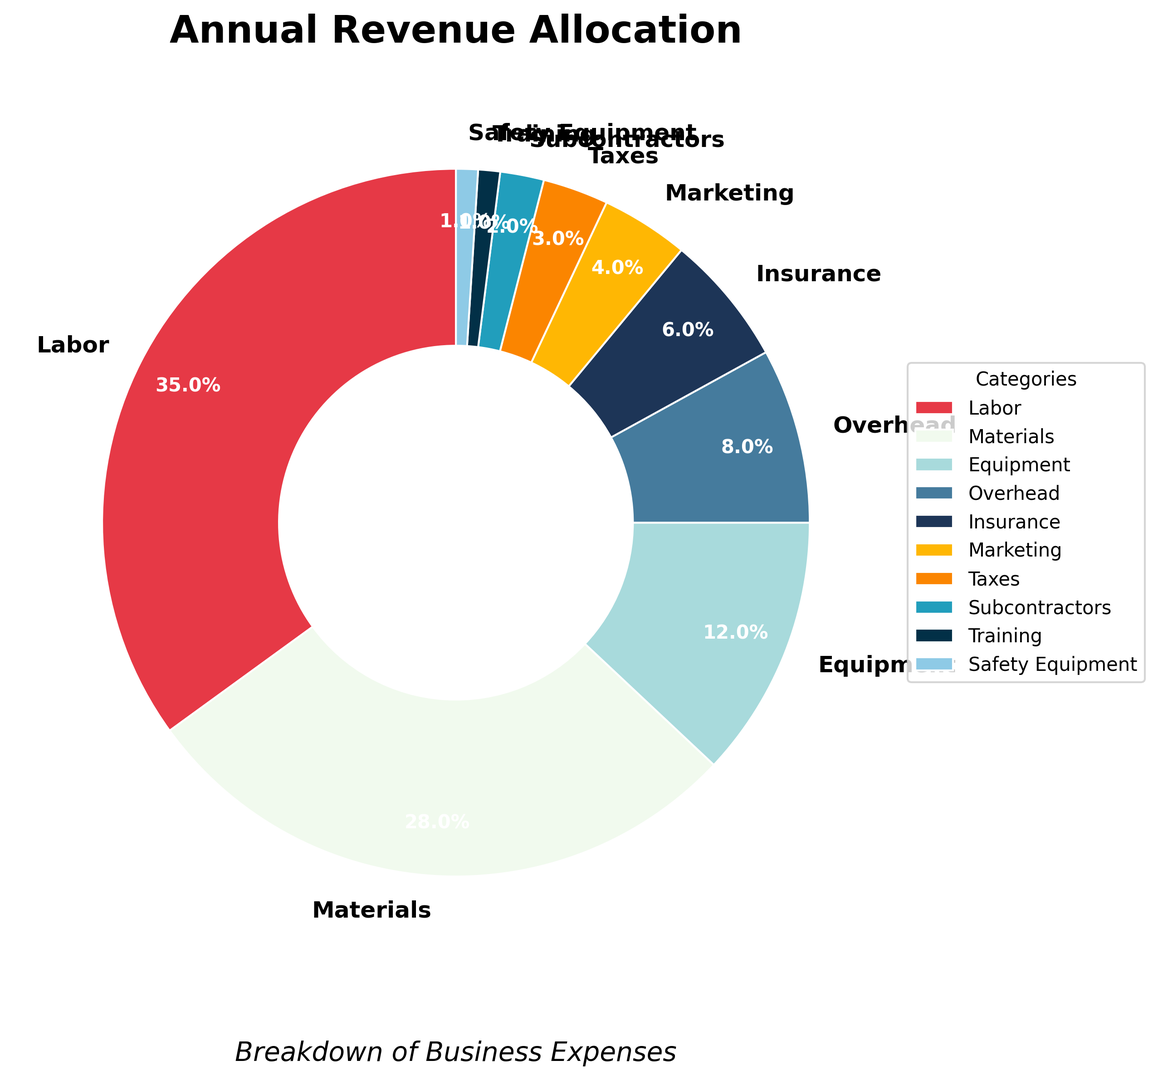What percentage of the annual revenue is allocated to Labor and Materials combined? To find the combined percentage of Labor and Materials, add their individual percentages: Labor is 35% and Materials is 28%. The sum is 35% + 28% = 63%.
Answer: 63% Which category has the smallest percentage allocation of annual revenue? By examining the pie chart, the smallest slice corresponds to either Training or Safety Equipment, both at 1%.
Answer: Training and Safety Equipment How much larger is the allocation for Equipment compared to Marketing? Equipment is allocated 12%, and Marketing is allocated 4%. The difference is 12% - 4% = 8%.
Answer: 8% Is the percentage allocated to Overhead greater than the percentage allocated to Insurance? By comparing the two slices in the pie chart, Overhead is 8% and Insurance is 6%, so Overhead's allocation is indeed larger.
Answer: Yes What is the total percentage of revenue allocated to Marketing, Taxes, Subcontractors, Training, and Safety Equipment combined? Adding the percentages for Marketing (4%), Taxes (3%), Subcontractors (2%), Training (1%), and Safety Equipment (1%) gives 4% + 3% + 2% + 1% + 1% = 11%.
Answer: 11% Which category's allocation is represented by the darkest shade of blue? Looking at the pie chart, the darkest shade of blue corresponds to Taxes, which has a 3% allocation.
Answer: Taxes Compare the allocation for Labor to the combined allocation for Overhead and Insurance. Labor is allocated 35%. The combined allocation for Overhead (8%) and Insurance (6%) is 8% + 6% = 14%. Comparing the two, Labor's allocation is higher.
Answer: Labor is higher What is the total percentage allocated to categories whose individual allocations are less than 5%? Categories with less than 5% are Marketing (4%), Taxes (3%), Subcontractors (2%), Training (1%), and Safety Equipment (1%). Adding these percentages: 4% + 3% + 2% + 1% + 1% = 11%.
Answer: 11% Which categories have allocations between 5% to 10%, inclusive? Categories within this range are Overhead at 8% and Insurance at 6%.
Answer: Overhead and Insurance 